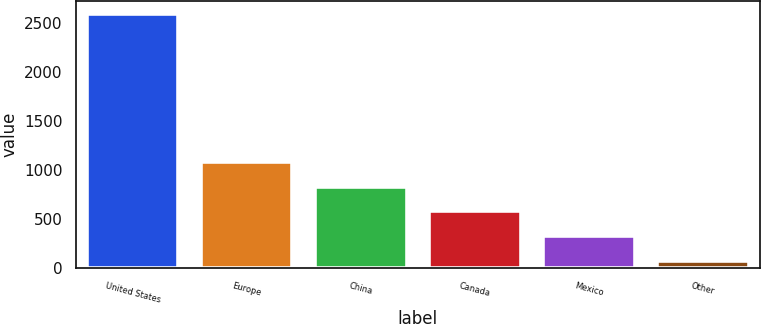<chart> <loc_0><loc_0><loc_500><loc_500><bar_chart><fcel>United States<fcel>Europe<fcel>China<fcel>Canada<fcel>Mexico<fcel>Other<nl><fcel>2599<fcel>1084<fcel>831.5<fcel>579<fcel>326.5<fcel>74<nl></chart> 